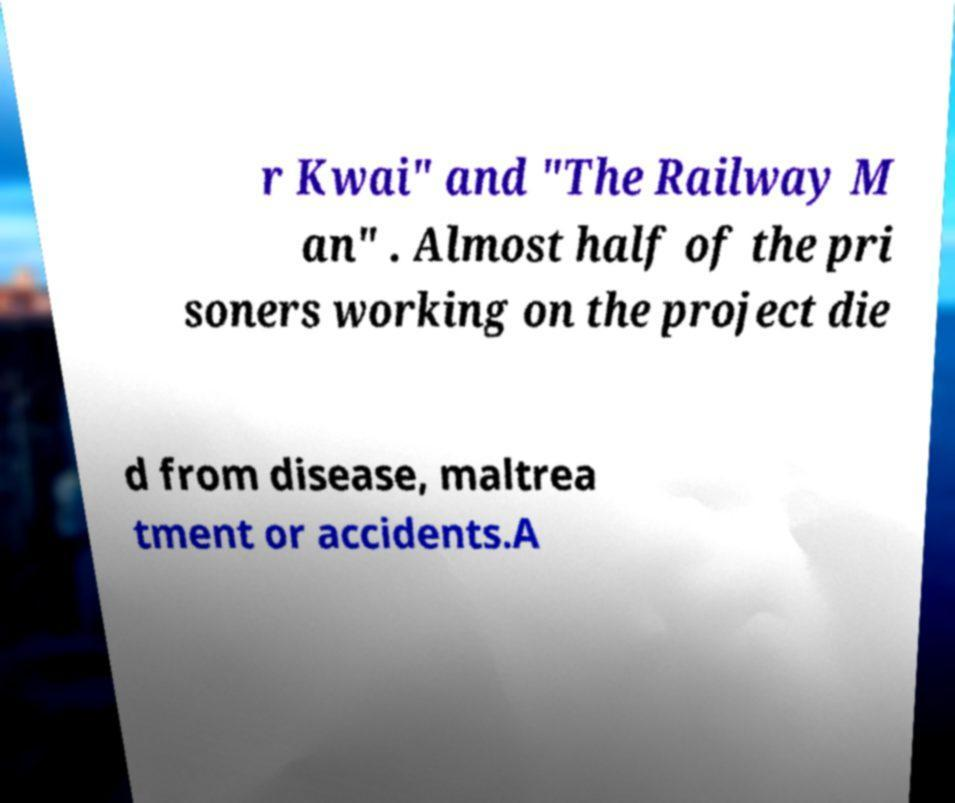For documentation purposes, I need the text within this image transcribed. Could you provide that? r Kwai" and "The Railway M an" . Almost half of the pri soners working on the project die d from disease, maltrea tment or accidents.A 